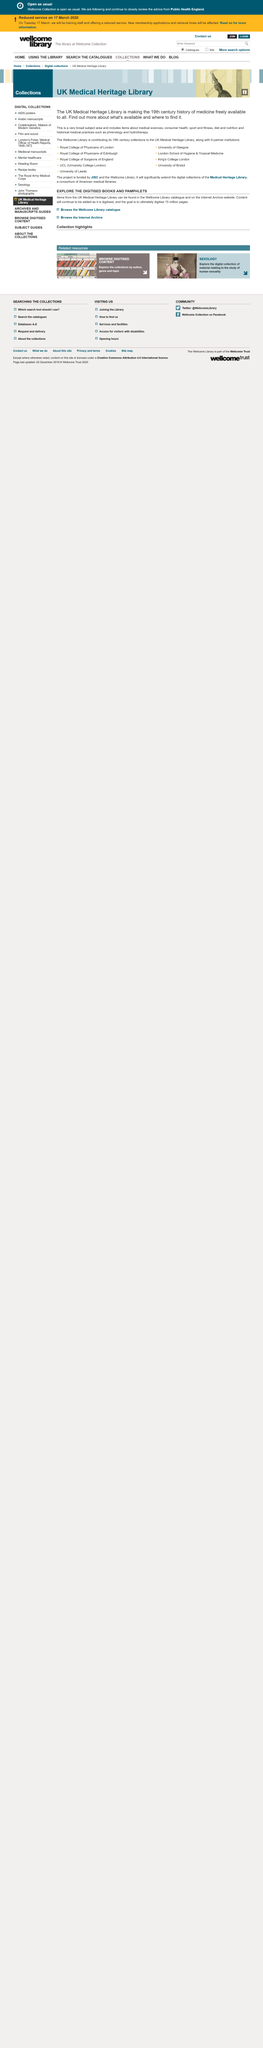Specify some key components in this picture. The UK Medical Heritage Library is making the 19th century history of medicine freely available. The UK Medical Heritage Library includes a wide range of resources related to medical sciences, consumer health, sport and fitness, diet and nutrition, and historical medical practices. The subject areas of medical anthropology mention historical medical practices such as phrenology and hydrotherapy. 